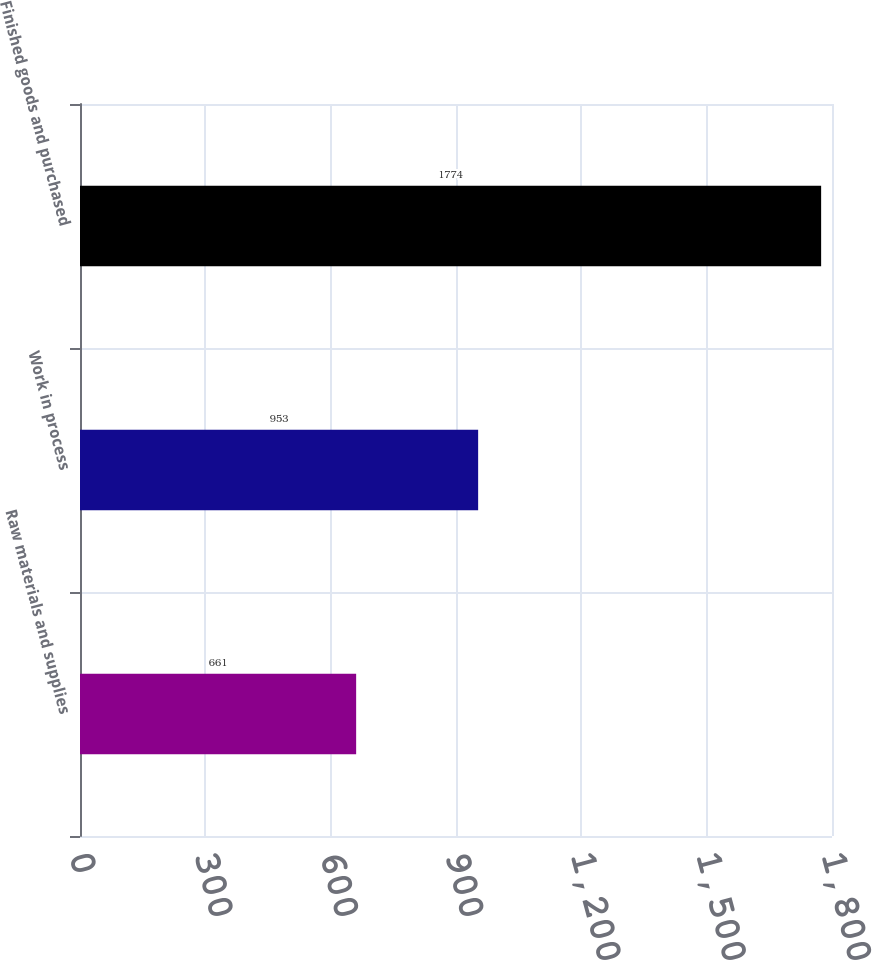Convert chart to OTSL. <chart><loc_0><loc_0><loc_500><loc_500><bar_chart><fcel>Raw materials and supplies<fcel>Work in process<fcel>Finished goods and purchased<nl><fcel>661<fcel>953<fcel>1774<nl></chart> 